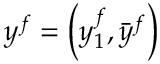<formula> <loc_0><loc_0><loc_500><loc_500>y ^ { f } = \left ( y _ { 1 } ^ { f } , { \bar { y } } ^ { f } \right )</formula> 